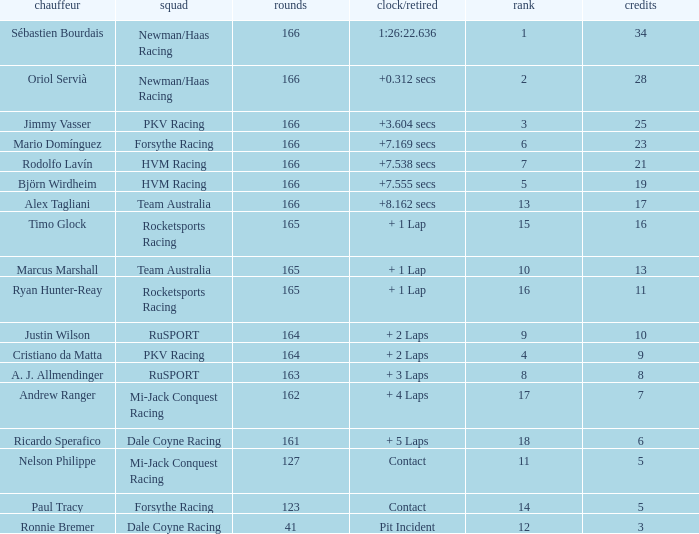What grid is the lowest when the time/retired is + 5 laps and the laps is less than 161? None. 